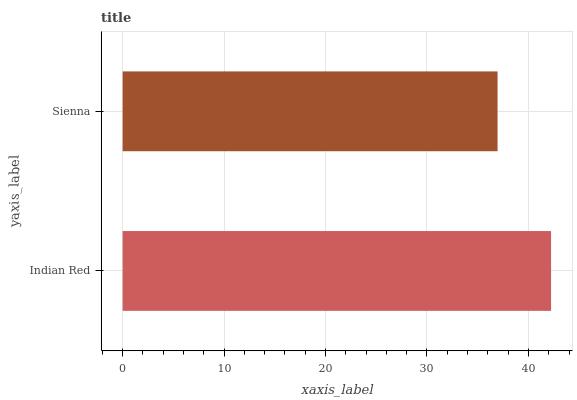Is Sienna the minimum?
Answer yes or no. Yes. Is Indian Red the maximum?
Answer yes or no. Yes. Is Sienna the maximum?
Answer yes or no. No. Is Indian Red greater than Sienna?
Answer yes or no. Yes. Is Sienna less than Indian Red?
Answer yes or no. Yes. Is Sienna greater than Indian Red?
Answer yes or no. No. Is Indian Red less than Sienna?
Answer yes or no. No. Is Indian Red the high median?
Answer yes or no. Yes. Is Sienna the low median?
Answer yes or no. Yes. Is Sienna the high median?
Answer yes or no. No. Is Indian Red the low median?
Answer yes or no. No. 